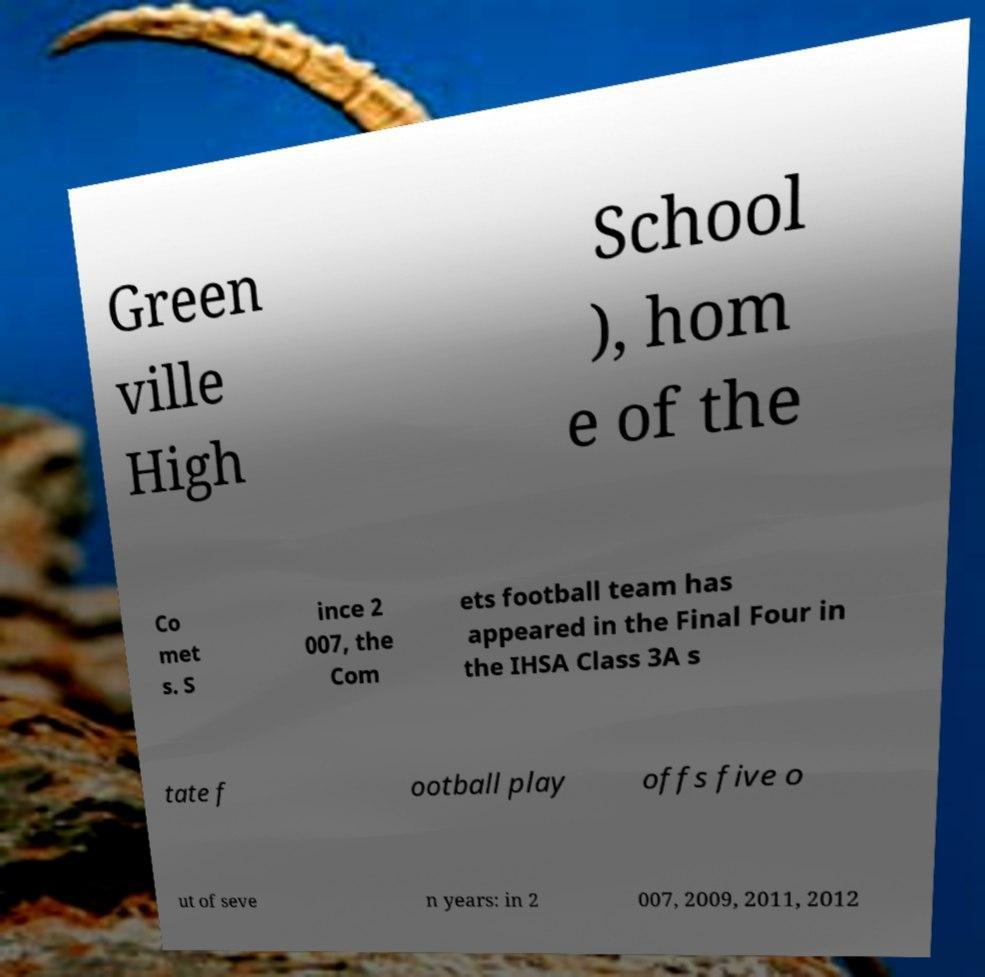I need the written content from this picture converted into text. Can you do that? Green ville High School ), hom e of the Co met s. S ince 2 007, the Com ets football team has appeared in the Final Four in the IHSA Class 3A s tate f ootball play offs five o ut of seve n years: in 2 007, 2009, 2011, 2012 